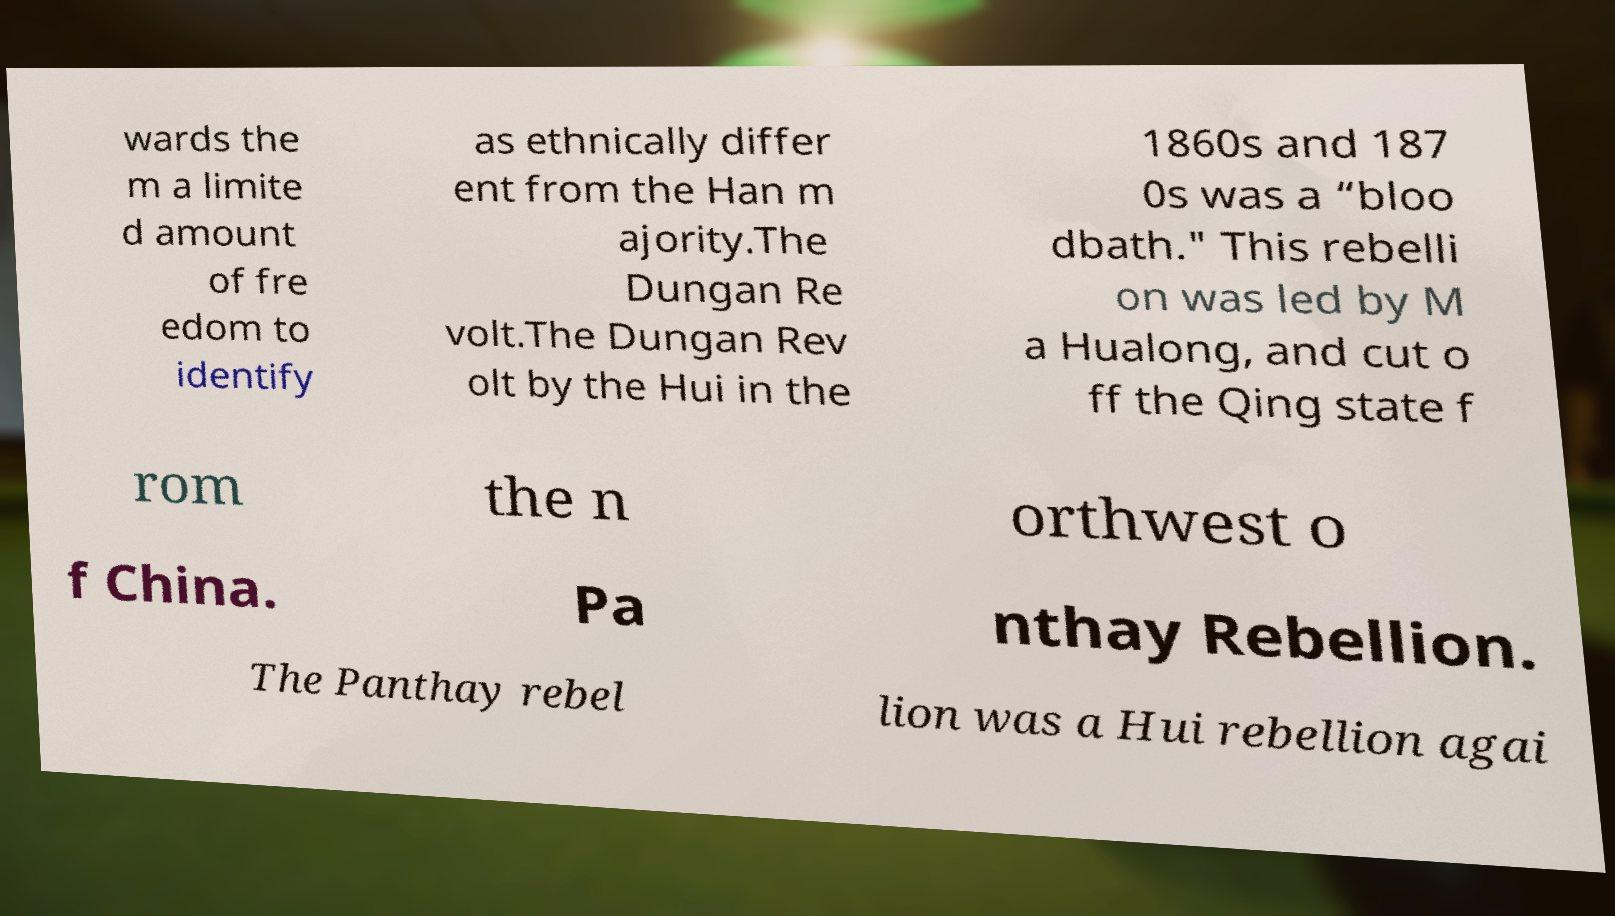Can you read and provide the text displayed in the image?This photo seems to have some interesting text. Can you extract and type it out for me? wards the m a limite d amount of fre edom to identify as ethnically differ ent from the Han m ajority.The Dungan Re volt.The Dungan Rev olt by the Hui in the 1860s and 187 0s was a “bloo dbath." This rebelli on was led by M a Hualong, and cut o ff the Qing state f rom the n orthwest o f China. Pa nthay Rebellion. The Panthay rebel lion was a Hui rebellion agai 